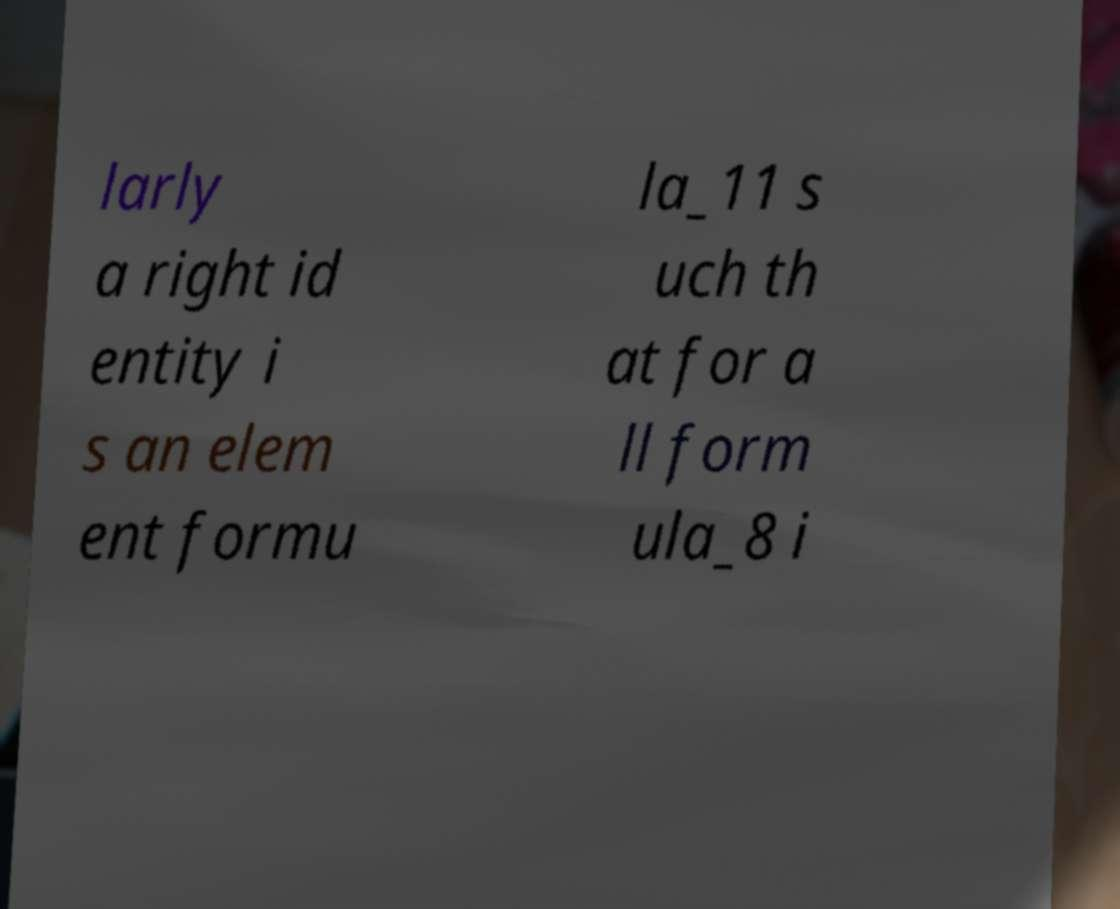Can you read and provide the text displayed in the image?This photo seems to have some interesting text. Can you extract and type it out for me? larly a right id entity i s an elem ent formu la_11 s uch th at for a ll form ula_8 i 